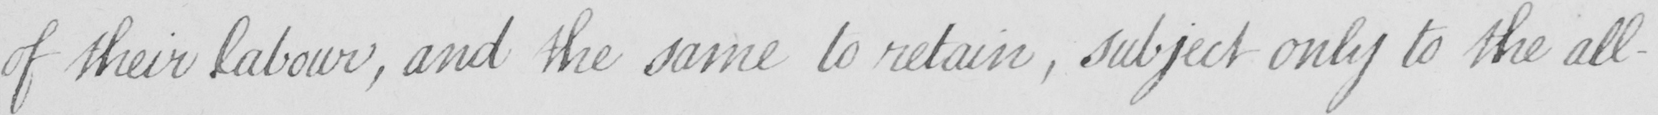What is written in this line of handwriting? of their labour , and the same to retain  , subject only to the all- 